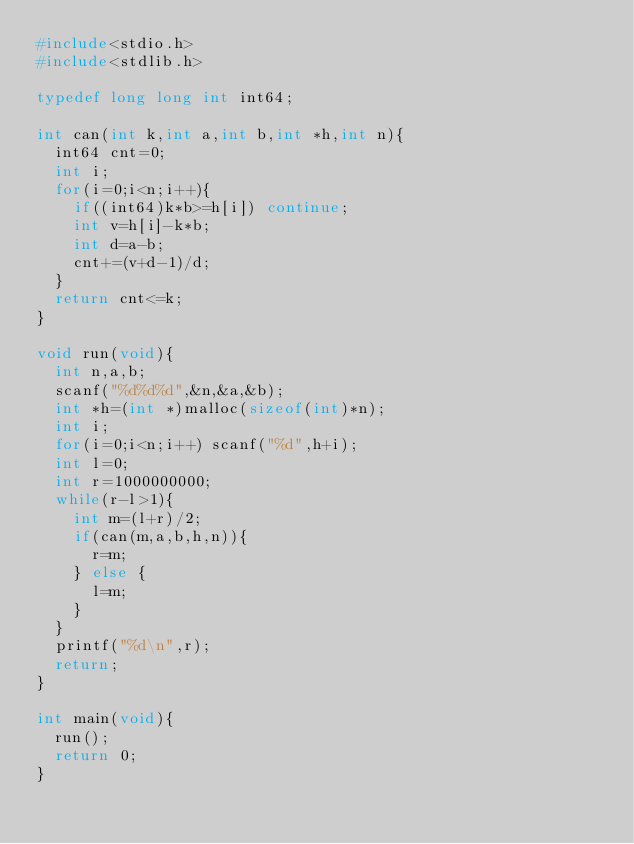Convert code to text. <code><loc_0><loc_0><loc_500><loc_500><_C_>#include<stdio.h>
#include<stdlib.h>

typedef long long int int64;

int can(int k,int a,int b,int *h,int n){
  int64 cnt=0;
  int i;
  for(i=0;i<n;i++){
    if((int64)k*b>=h[i]) continue;
    int v=h[i]-k*b;
    int d=a-b;
    cnt+=(v+d-1)/d;
  }
  return cnt<=k;
}

void run(void){
  int n,a,b;
  scanf("%d%d%d",&n,&a,&b);
  int *h=(int *)malloc(sizeof(int)*n);
  int i;
  for(i=0;i<n;i++) scanf("%d",h+i);
  int l=0;
  int r=1000000000;
  while(r-l>1){
    int m=(l+r)/2;
    if(can(m,a,b,h,n)){
      r=m;
    } else {
      l=m;
    }
  }
  printf("%d\n",r);
  return;
}

int main(void){
  run();
  return 0;
}
</code> 